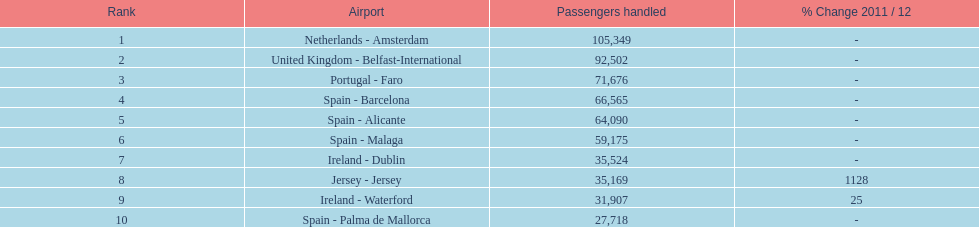Which airport managed more passengers than the united kingdom? Netherlands - Amsterdam. 